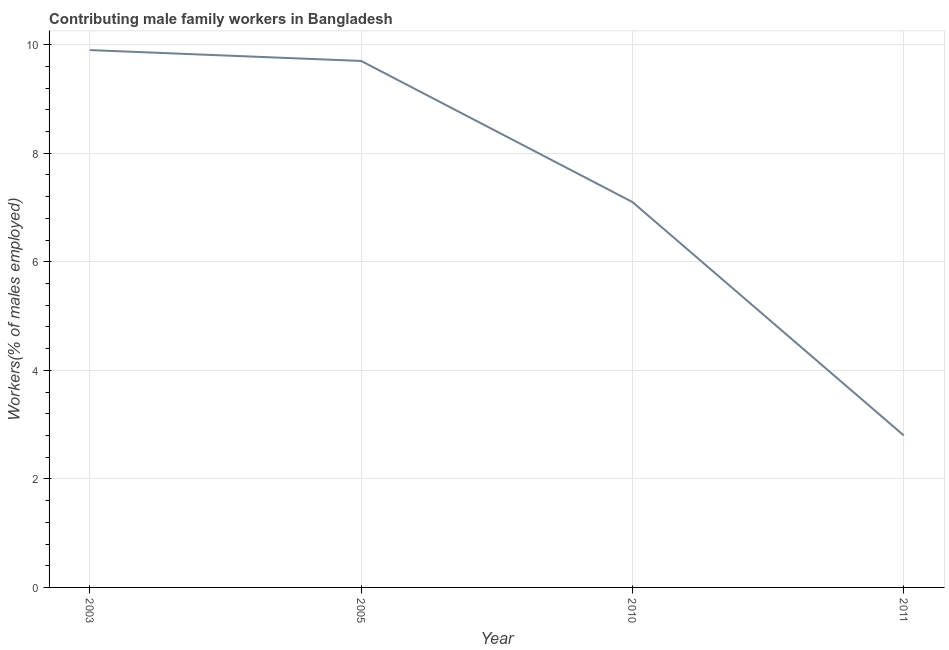What is the contributing male family workers in 2010?
Your answer should be compact. 7.1. Across all years, what is the maximum contributing male family workers?
Ensure brevity in your answer.  9.9. Across all years, what is the minimum contributing male family workers?
Make the answer very short. 2.8. What is the sum of the contributing male family workers?
Your answer should be very brief. 29.5. What is the difference between the contributing male family workers in 2010 and 2011?
Give a very brief answer. 4.3. What is the average contributing male family workers per year?
Your answer should be very brief. 7.37. What is the median contributing male family workers?
Give a very brief answer. 8.4. In how many years, is the contributing male family workers greater than 1.6 %?
Ensure brevity in your answer.  4. What is the ratio of the contributing male family workers in 2005 to that in 2011?
Keep it short and to the point. 3.46. What is the difference between the highest and the second highest contributing male family workers?
Your answer should be very brief. 0.2. What is the difference between the highest and the lowest contributing male family workers?
Your response must be concise. 7.1. In how many years, is the contributing male family workers greater than the average contributing male family workers taken over all years?
Provide a succinct answer. 2. Does the contributing male family workers monotonically increase over the years?
Offer a terse response. No. How many lines are there?
Ensure brevity in your answer.  1. What is the difference between two consecutive major ticks on the Y-axis?
Offer a terse response. 2. Are the values on the major ticks of Y-axis written in scientific E-notation?
Your answer should be compact. No. Does the graph contain any zero values?
Your response must be concise. No. Does the graph contain grids?
Provide a succinct answer. Yes. What is the title of the graph?
Provide a short and direct response. Contributing male family workers in Bangladesh. What is the label or title of the X-axis?
Provide a succinct answer. Year. What is the label or title of the Y-axis?
Your answer should be very brief. Workers(% of males employed). What is the Workers(% of males employed) in 2003?
Your response must be concise. 9.9. What is the Workers(% of males employed) of 2005?
Offer a terse response. 9.7. What is the Workers(% of males employed) of 2010?
Keep it short and to the point. 7.1. What is the Workers(% of males employed) in 2011?
Offer a very short reply. 2.8. What is the difference between the Workers(% of males employed) in 2003 and 2010?
Provide a short and direct response. 2.8. What is the difference between the Workers(% of males employed) in 2003 and 2011?
Give a very brief answer. 7.1. What is the difference between the Workers(% of males employed) in 2005 and 2010?
Offer a terse response. 2.6. What is the difference between the Workers(% of males employed) in 2010 and 2011?
Keep it short and to the point. 4.3. What is the ratio of the Workers(% of males employed) in 2003 to that in 2005?
Your response must be concise. 1.02. What is the ratio of the Workers(% of males employed) in 2003 to that in 2010?
Your answer should be compact. 1.39. What is the ratio of the Workers(% of males employed) in 2003 to that in 2011?
Provide a short and direct response. 3.54. What is the ratio of the Workers(% of males employed) in 2005 to that in 2010?
Give a very brief answer. 1.37. What is the ratio of the Workers(% of males employed) in 2005 to that in 2011?
Keep it short and to the point. 3.46. What is the ratio of the Workers(% of males employed) in 2010 to that in 2011?
Give a very brief answer. 2.54. 